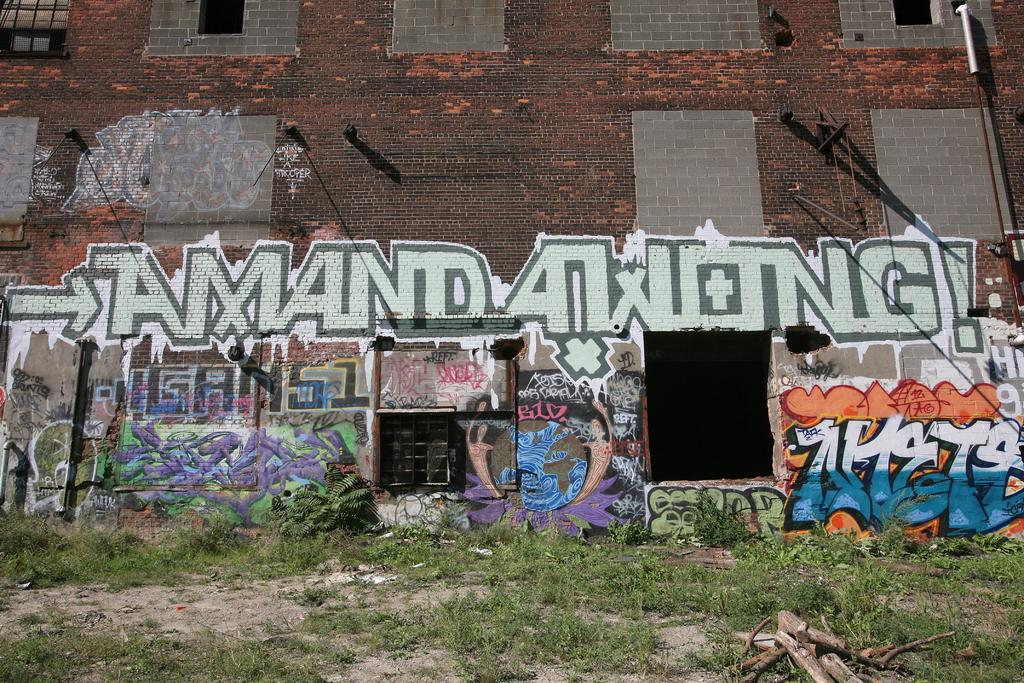What type of natural environment is visible in the image? There is grass visible in the image. What objects can be seen in the image that are made of wood? There are sticks in the image. What architectural features are present in the image? There are windows and rods visible in the image. What type of artwork is present in the image? There is a painting on a wall in the image. What type of fruit is being served on the throne in the image? There is no throne or fruit present in the image. What event is being celebrated in the image with the birth of a newborn? There is no event or newborn present in the image. 